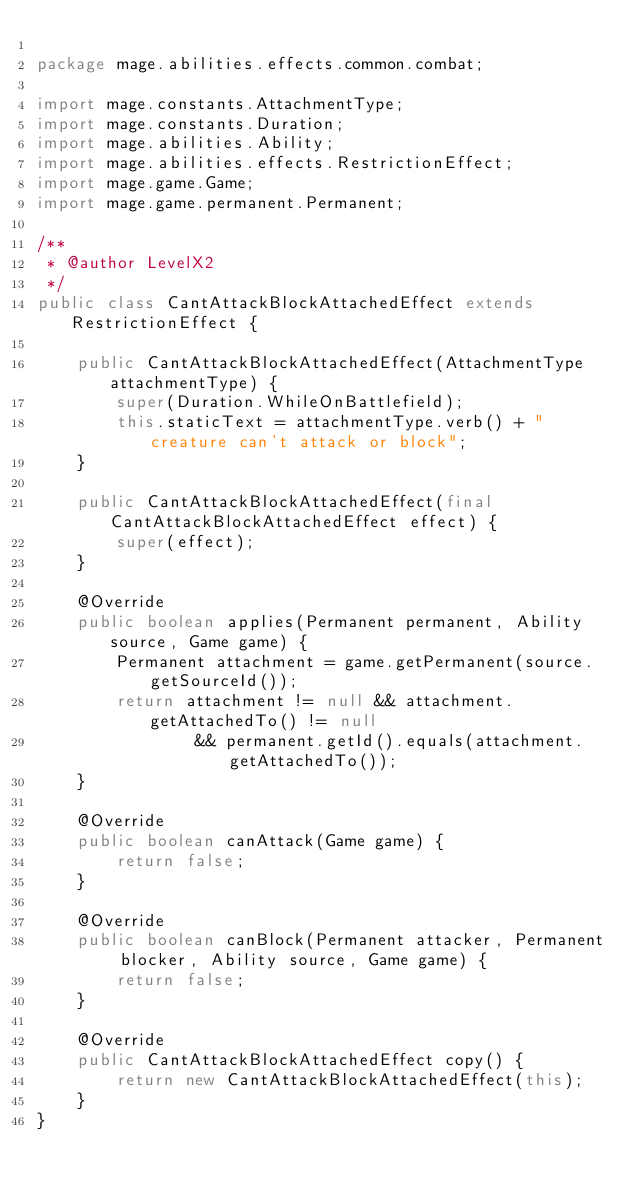<code> <loc_0><loc_0><loc_500><loc_500><_Java_>
package mage.abilities.effects.common.combat;

import mage.constants.AttachmentType;
import mage.constants.Duration;
import mage.abilities.Ability;
import mage.abilities.effects.RestrictionEffect;
import mage.game.Game;
import mage.game.permanent.Permanent;

/**
 * @author LevelX2
 */
public class CantAttackBlockAttachedEffect extends RestrictionEffect {

    public CantAttackBlockAttachedEffect(AttachmentType attachmentType) {
        super(Duration.WhileOnBattlefield);
        this.staticText = attachmentType.verb() + " creature can't attack or block";
    }

    public CantAttackBlockAttachedEffect(final CantAttackBlockAttachedEffect effect) {
        super(effect);
    }

    @Override
    public boolean applies(Permanent permanent, Ability source, Game game) {
        Permanent attachment = game.getPermanent(source.getSourceId());
        return attachment != null && attachment.getAttachedTo() != null
                && permanent.getId().equals(attachment.getAttachedTo());
    }

    @Override
    public boolean canAttack(Game game) {
        return false;
    }

    @Override
    public boolean canBlock(Permanent attacker, Permanent blocker, Ability source, Game game) {
        return false;
    }

    @Override
    public CantAttackBlockAttachedEffect copy() {
        return new CantAttackBlockAttachedEffect(this);
    }
}
</code> 